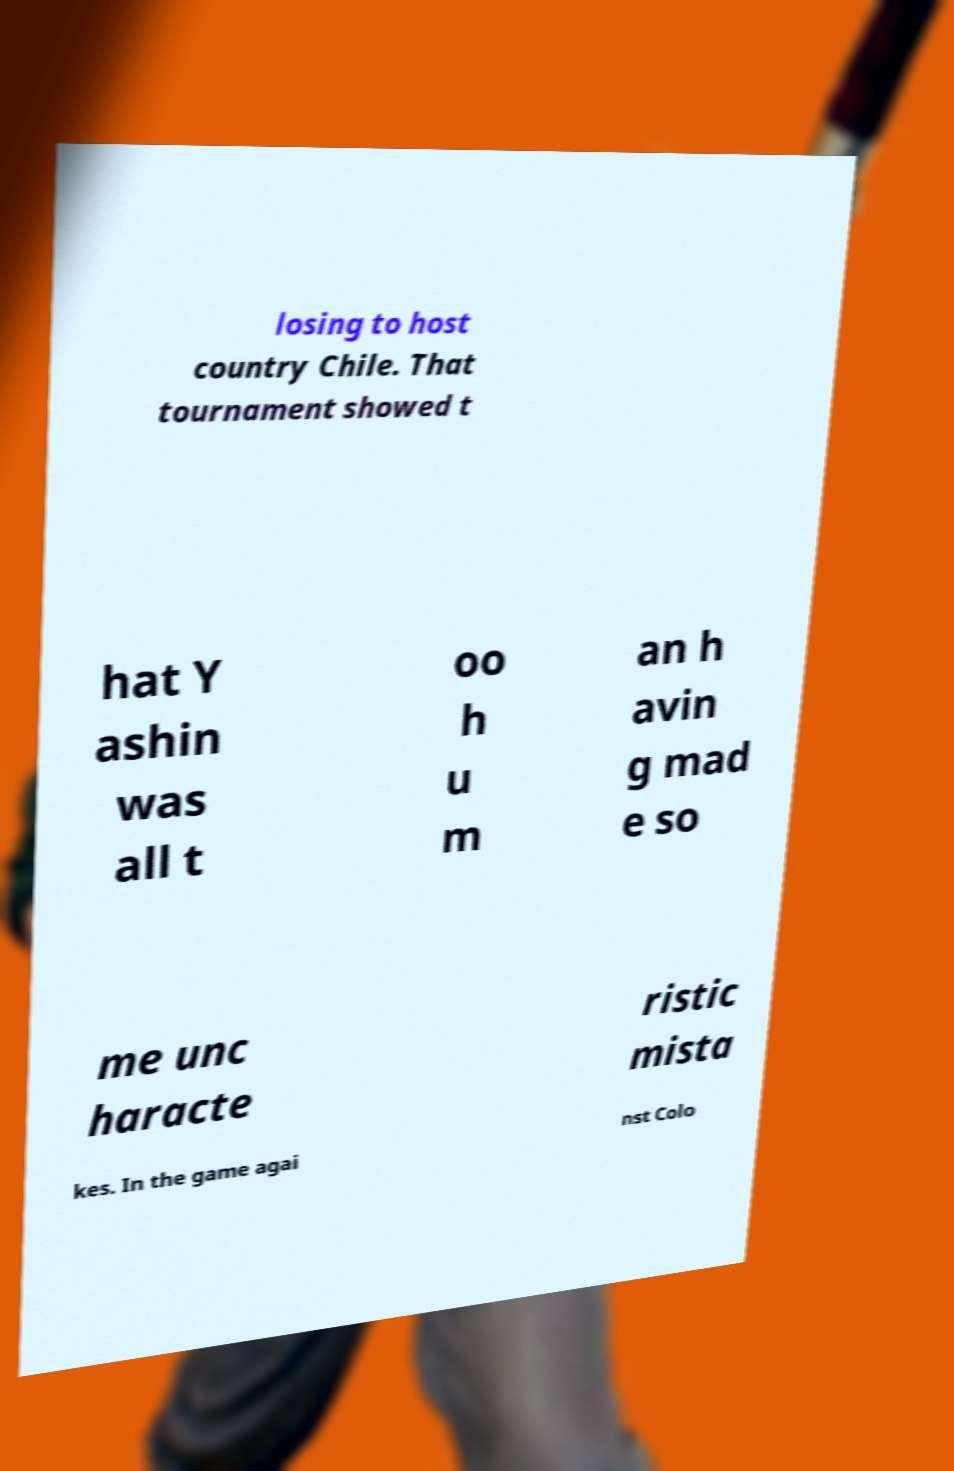Can you accurately transcribe the text from the provided image for me? losing to host country Chile. That tournament showed t hat Y ashin was all t oo h u m an h avin g mad e so me unc haracte ristic mista kes. In the game agai nst Colo 